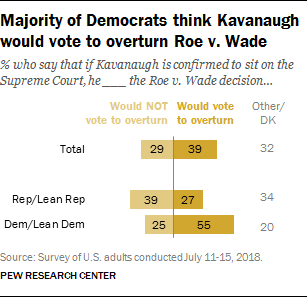Point out several critical features in this image. If the sum of 'Total' and 'Dem/Lean Dem' in the 'Would vote to overturn' column is greater than the 'Would Not vote to overturn' column, then it indicates that more people are in favor of overturning the impeachment verdict than those who are against it. The value "39" in the chart represents the number of representatives or lean Republican lawmakers who indicated that they would not vote to overturn the President's veto in the event of a disagreement over the annual defense appropriations bill. 